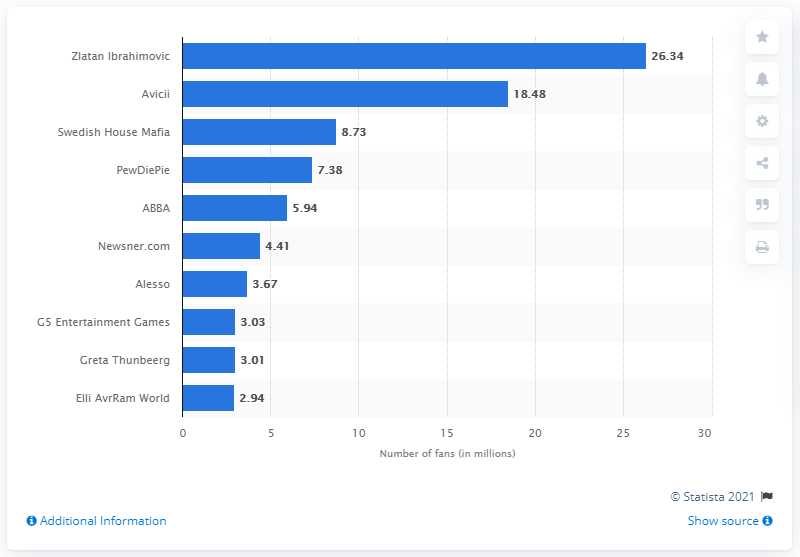Specify some key components in this picture. The most popular Facebook page in Sweden in January 2021 was Zlatan Ibrahimovic. 